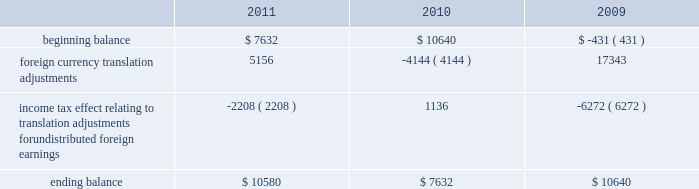The table sets forth the components of foreign currency translation adjustments for fiscal 2011 , 2010 and 2009 ( in thousands ) : beginning balance foreign currency translation adjustments income tax effect relating to translation adjustments for undistributed foreign earnings ending balance $ 7632 ( 2208 ) $ 10580 $ 10640 ( 4144 ) $ 7632 $ ( 431 ) 17343 ( 6272 ) $ 10640 stock repurchase program to facilitate our stock repurchase program , designed to return value to our stockholders and minimize dilution from stock issuances , we repurchase shares in the open market and also enter into structured repurchase agreements with third-parties .
Authorization to repurchase shares to cover on-going dilution was not subject to expiration .
However , this repurchase program was limited to covering net dilution from stock issuances and was subject to business conditions and cash flow requirements as determined by our board of directors from time to time .
During the third quarter of fiscal 2010 , our board of directors approved an amendment to our stock repurchase program authorized in april 2007 from a non-expiring share-based authority to a time-constrained dollar-based authority .
As part of this amendment , the board of directors granted authority to repurchase up to $ 1.6 billion in common stock through the end of fiscal 2012 .
This amended program did not affect the $ 250.0 million structured stock repurchase agreement entered into during march 2010 .
As of december 3 , 2010 , no prepayments remain under that agreement .
During fiscal 2011 , 2010 and 2009 , we entered into several structured repurchase agreements with large financial institutions , whereupon we provided the financial institutions with prepayments totaling $ 695.0 million , $ 850.0 million and $ 350.0 million , respectively .
Of the $ 850.0 million of prepayments during fiscal 2010 , $ 250.0 million was under the stock repurchase program prior to the program amendment and the remaining $ 600.0 million was under the amended $ 1.6 billion time-constrained dollar- based authority .
We enter into these agreements in order to take advantage of repurchasing shares at a guaranteed discount to the volume weighted average price ( 201cvwap 201d ) of our common stock over a specified period of time .
We only enter into such transactions when the discount that we receive is higher than the foregone return on our cash prepayments to the financial institutions .
There were no explicit commissions or fees on these structured repurchases .
Under the terms of the agreements , there is no requirement for the financial institutions to return any portion of the prepayment to us .
The financial institutions agree to deliver shares to us at monthly intervals during the contract term .
The parameters used to calculate the number of shares deliverable are : the total notional amount of the contract , the number of trading days in the contract , the number of trading days in the interval and the average vwap of our stock during the interval less the agreed upon discount .
During fiscal 2011 , we repurchased approximately 21.8 million shares at an average price of $ 31.81 through structured repurchase agreements entered into during fiscal 2011 .
During fiscal 2010 , we repurchased approximately 31.2 million shares at an average price of $ 29.19 through structured repurchase agreements entered into during fiscal 2009 and fiscal 2010 .
During fiscal 2009 , we repurchased approximately 15.2 million shares at an average price per share of $ 27.89 through structured repurchase agreements entered into during fiscal 2008 and fiscal 2009 .
For fiscal 2011 , 2010 and 2009 , the prepayments were classified as treasury stock on our consolidated balance sheets at the payment date , though only shares physically delivered to us by december 2 , 2011 , december 3 , 2010 and november 27 , 2009 were excluded from the computation of earnings per share .
As of december 2 , 2011 and december 3 , 2010 , no prepayments remained under these agreements .
As of november 27 , 2009 , approximately $ 59.9 million of prepayments remained under these agreements .
Subsequent to december 2 , 2011 , as part of our $ 1.6 billion stock repurchase program , we entered into a structured stock repurchase agreement with a large financial institution whereupon we provided them with a prepayment of $ 80.0 million .
This amount will be classified as treasury stock on our consolidated balance sheets .
Upon completion of the $ 80.0 million stock table of contents adobe systems incorporated notes to consolidated financial statements ( continued ) jarcamo typewritten text .
The following table sets forth the components of foreign currency translation adjustments for fiscal 2011 , 2010 and 2009 ( in thousands ) : beginning balance foreign currency translation adjustments income tax effect relating to translation adjustments for undistributed foreign earnings ending balance $ 7632 ( 2208 ) $ 10580 $ 10640 ( 4144 ) $ 7632 $ ( 431 ) 17343 ( 6272 ) $ 10640 stock repurchase program to facilitate our stock repurchase program , designed to return value to our stockholders and minimize dilution from stock issuances , we repurchase shares in the open market and also enter into structured repurchase agreements with third-parties .
Authorization to repurchase shares to cover on-going dilution was not subject to expiration .
However , this repurchase program was limited to covering net dilution from stock issuances and was subject to business conditions and cash flow requirements as determined by our board of directors from time to time .
During the third quarter of fiscal 2010 , our board of directors approved an amendment to our stock repurchase program authorized in april 2007 from a non-expiring share-based authority to a time-constrained dollar-based authority .
As part of this amendment , the board of directors granted authority to repurchase up to $ 1.6 billion in common stock through the end of fiscal 2012 .
This amended program did not affect the $ 250.0 million structured stock repurchase agreement entered into during march 2010 .
As of december 3 , 2010 , no prepayments remain under that agreement .
During fiscal 2011 , 2010 and 2009 , we entered into several structured repurchase agreements with large financial institutions , whereupon we provided the financial institutions with prepayments totaling $ 695.0 million , $ 850.0 million and $ 350.0 million , respectively .
Of the $ 850.0 million of prepayments during fiscal 2010 , $ 250.0 million was under the stock repurchase program prior to the program amendment and the remaining $ 600.0 million was under the amended $ 1.6 billion time-constrained dollar- based authority .
We enter into these agreements in order to take advantage of repurchasing shares at a guaranteed discount to the volume weighted average price ( 201cvwap 201d ) of our common stock over a specified period of time .
We only enter into such transactions when the discount that we receive is higher than the foregone return on our cash prepayments to the financial institutions .
There were no explicit commissions or fees on these structured repurchases .
Under the terms of the agreements , there is no requirement for the financial institutions to return any portion of the prepayment to us .
The financial institutions agree to deliver shares to us at monthly intervals during the contract term .
The parameters used to calculate the number of shares deliverable are : the total notional amount of the contract , the number of trading days in the contract , the number of trading days in the interval and the average vwap of our stock during the interval less the agreed upon discount .
During fiscal 2011 , we repurchased approximately 21.8 million shares at an average price of $ 31.81 through structured repurchase agreements entered into during fiscal 2011 .
During fiscal 2010 , we repurchased approximately 31.2 million shares at an average price of $ 29.19 through structured repurchase agreements entered into during fiscal 2009 and fiscal 2010 .
During fiscal 2009 , we repurchased approximately 15.2 million shares at an average price per share of $ 27.89 through structured repurchase agreements entered into during fiscal 2008 and fiscal 2009 .
For fiscal 2011 , 2010 and 2009 , the prepayments were classified as treasury stock on our consolidated balance sheets at the payment date , though only shares physically delivered to us by december 2 , 2011 , december 3 , 2010 and november 27 , 2009 were excluded from the computation of earnings per share .
As of december 2 , 2011 and december 3 , 2010 , no prepayments remained under these agreements .
As of november 27 , 2009 , approximately $ 59.9 million of prepayments remained under these agreements .
Subsequent to december 2 , 2011 , as part of our $ 1.6 billion stock repurchase program , we entered into a structured stock repurchase agreement with a large financial institution whereupon we provided them with a prepayment of $ 80.0 million .
This amount will be classified as treasury stock on our consolidated balance sheets .
Upon completion of the $ 80.0 million stock table of contents adobe systems incorporated notes to consolidated financial statements ( continued ) jarcamo typewritten text .
For 2011 , was the impact of foreign currency translation adjustments greater than the income tax effect relating to translation adjustments for undistributed foreign earnings? 
Computations: (5156 > -2208)
Answer: yes. 